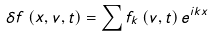Convert formula to latex. <formula><loc_0><loc_0><loc_500><loc_500>\delta f \left ( x , v , t \right ) = \sum f _ { k } \left ( v , t \right ) e ^ { i k x }</formula> 